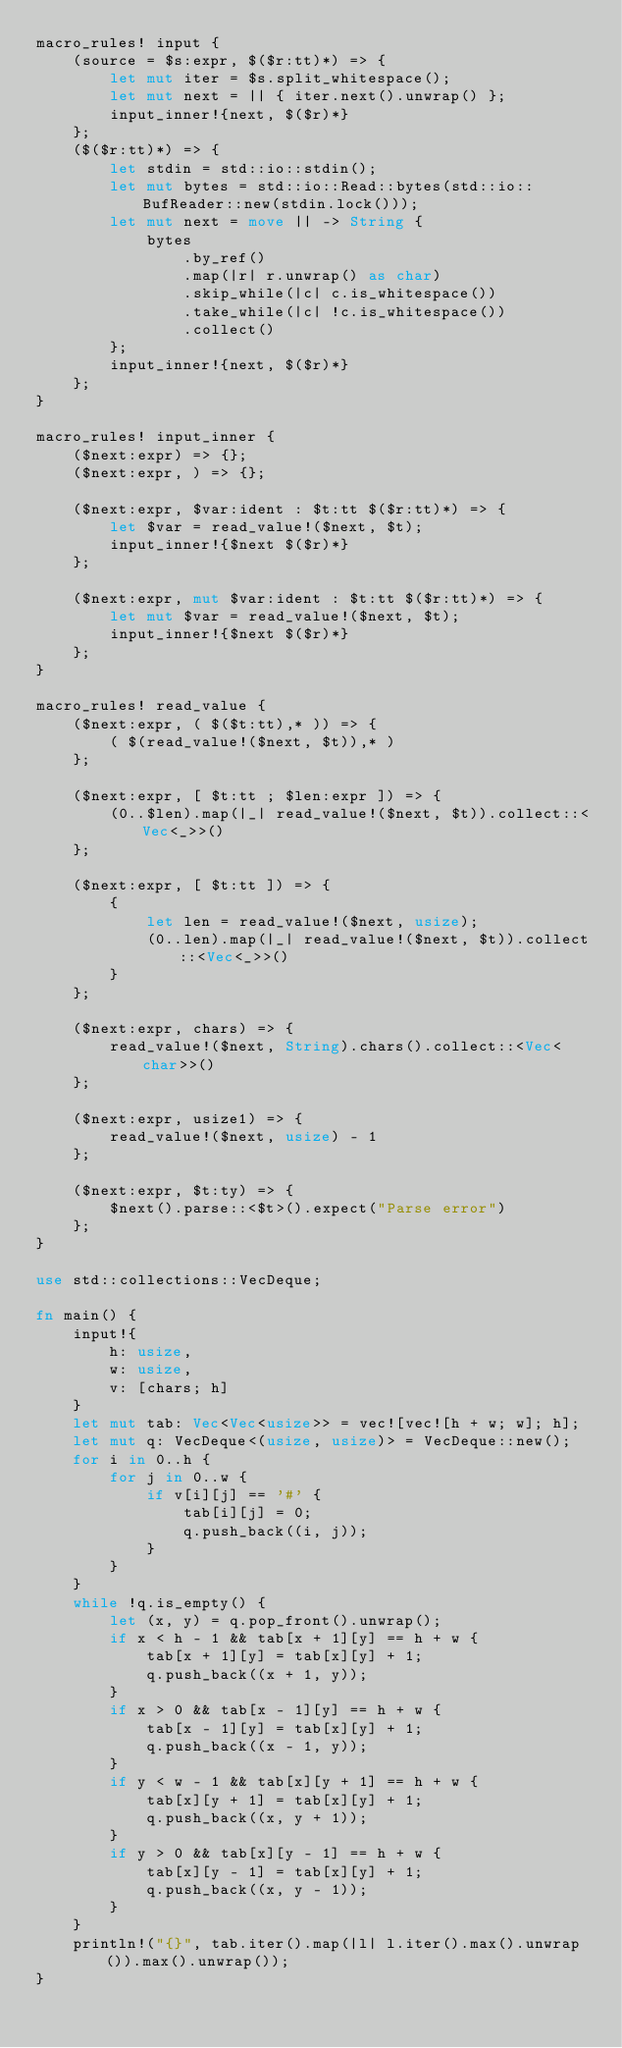Convert code to text. <code><loc_0><loc_0><loc_500><loc_500><_Rust_>macro_rules! input {
    (source = $s:expr, $($r:tt)*) => {
        let mut iter = $s.split_whitespace();
        let mut next = || { iter.next().unwrap() };
        input_inner!{next, $($r)*}
    };
    ($($r:tt)*) => {
        let stdin = std::io::stdin();
        let mut bytes = std::io::Read::bytes(std::io::BufReader::new(stdin.lock()));
        let mut next = move || -> String {
            bytes
                .by_ref()
                .map(|r| r.unwrap() as char)
                .skip_while(|c| c.is_whitespace())
                .take_while(|c| !c.is_whitespace())
                .collect()
        };
        input_inner!{next, $($r)*}
    };
}

macro_rules! input_inner {
    ($next:expr) => {};
    ($next:expr, ) => {};

    ($next:expr, $var:ident : $t:tt $($r:tt)*) => {
        let $var = read_value!($next, $t);
        input_inner!{$next $($r)*}
    };

    ($next:expr, mut $var:ident : $t:tt $($r:tt)*) => {
        let mut $var = read_value!($next, $t);
        input_inner!{$next $($r)*}
    };
}

macro_rules! read_value {
    ($next:expr, ( $($t:tt),* )) => {
        ( $(read_value!($next, $t)),* )
    };

    ($next:expr, [ $t:tt ; $len:expr ]) => {
        (0..$len).map(|_| read_value!($next, $t)).collect::<Vec<_>>()
    };

    ($next:expr, [ $t:tt ]) => {
        {
            let len = read_value!($next, usize);
            (0..len).map(|_| read_value!($next, $t)).collect::<Vec<_>>()
        }
    };

    ($next:expr, chars) => {
        read_value!($next, String).chars().collect::<Vec<char>>()
    };

    ($next:expr, usize1) => {
        read_value!($next, usize) - 1
    };

    ($next:expr, $t:ty) => {
        $next().parse::<$t>().expect("Parse error")
    };
}

use std::collections::VecDeque;

fn main() {
    input!{
        h: usize,
        w: usize,
        v: [chars; h]
    }
    let mut tab: Vec<Vec<usize>> = vec![vec![h + w; w]; h];
    let mut q: VecDeque<(usize, usize)> = VecDeque::new();
    for i in 0..h {
        for j in 0..w {
            if v[i][j] == '#' {
                tab[i][j] = 0;
                q.push_back((i, j));
            }
        }
    }
    while !q.is_empty() {
        let (x, y) = q.pop_front().unwrap();
        if x < h - 1 && tab[x + 1][y] == h + w {
            tab[x + 1][y] = tab[x][y] + 1;
            q.push_back((x + 1, y));
        }
        if x > 0 && tab[x - 1][y] == h + w {
            tab[x - 1][y] = tab[x][y] + 1;
            q.push_back((x - 1, y));
        }
        if y < w - 1 && tab[x][y + 1] == h + w {
            tab[x][y + 1] = tab[x][y] + 1;
            q.push_back((x, y + 1));
        }
        if y > 0 && tab[x][y - 1] == h + w {
            tab[x][y - 1] = tab[x][y] + 1;
            q.push_back((x, y - 1));
        }
    }
    println!("{}", tab.iter().map(|l| l.iter().max().unwrap()).max().unwrap());
}
</code> 